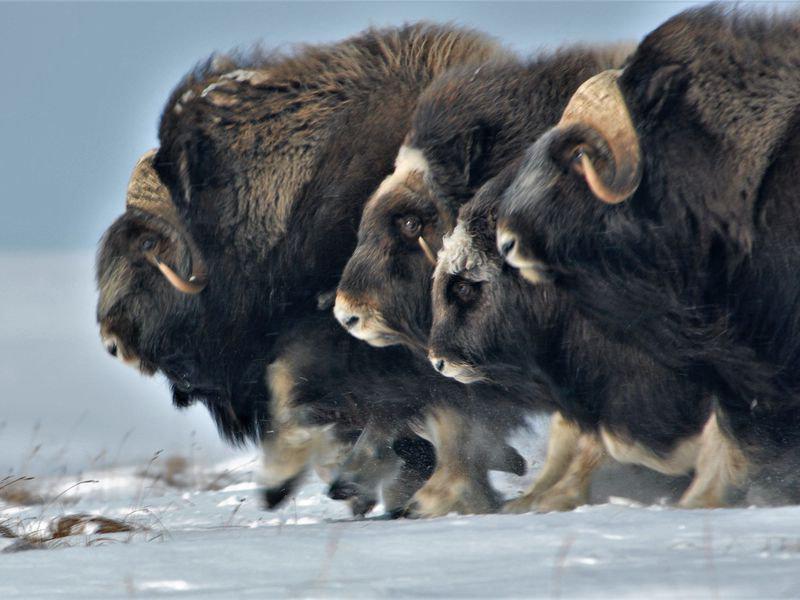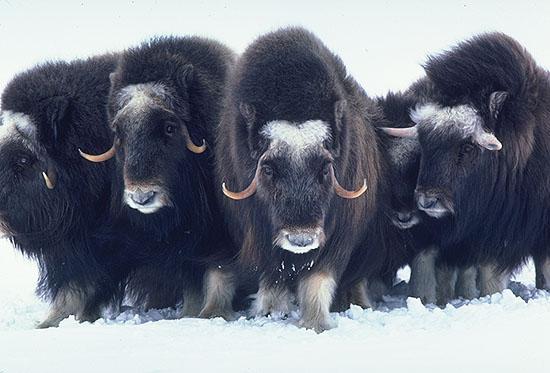The first image is the image on the left, the second image is the image on the right. Examine the images to the left and right. Is the description "There are 8 or more buffalo present in the snow." accurate? Answer yes or no. Yes. The first image is the image on the left, the second image is the image on the right. For the images shown, is this caption "In the left photo, there is only one buffalo." true? Answer yes or no. No. 